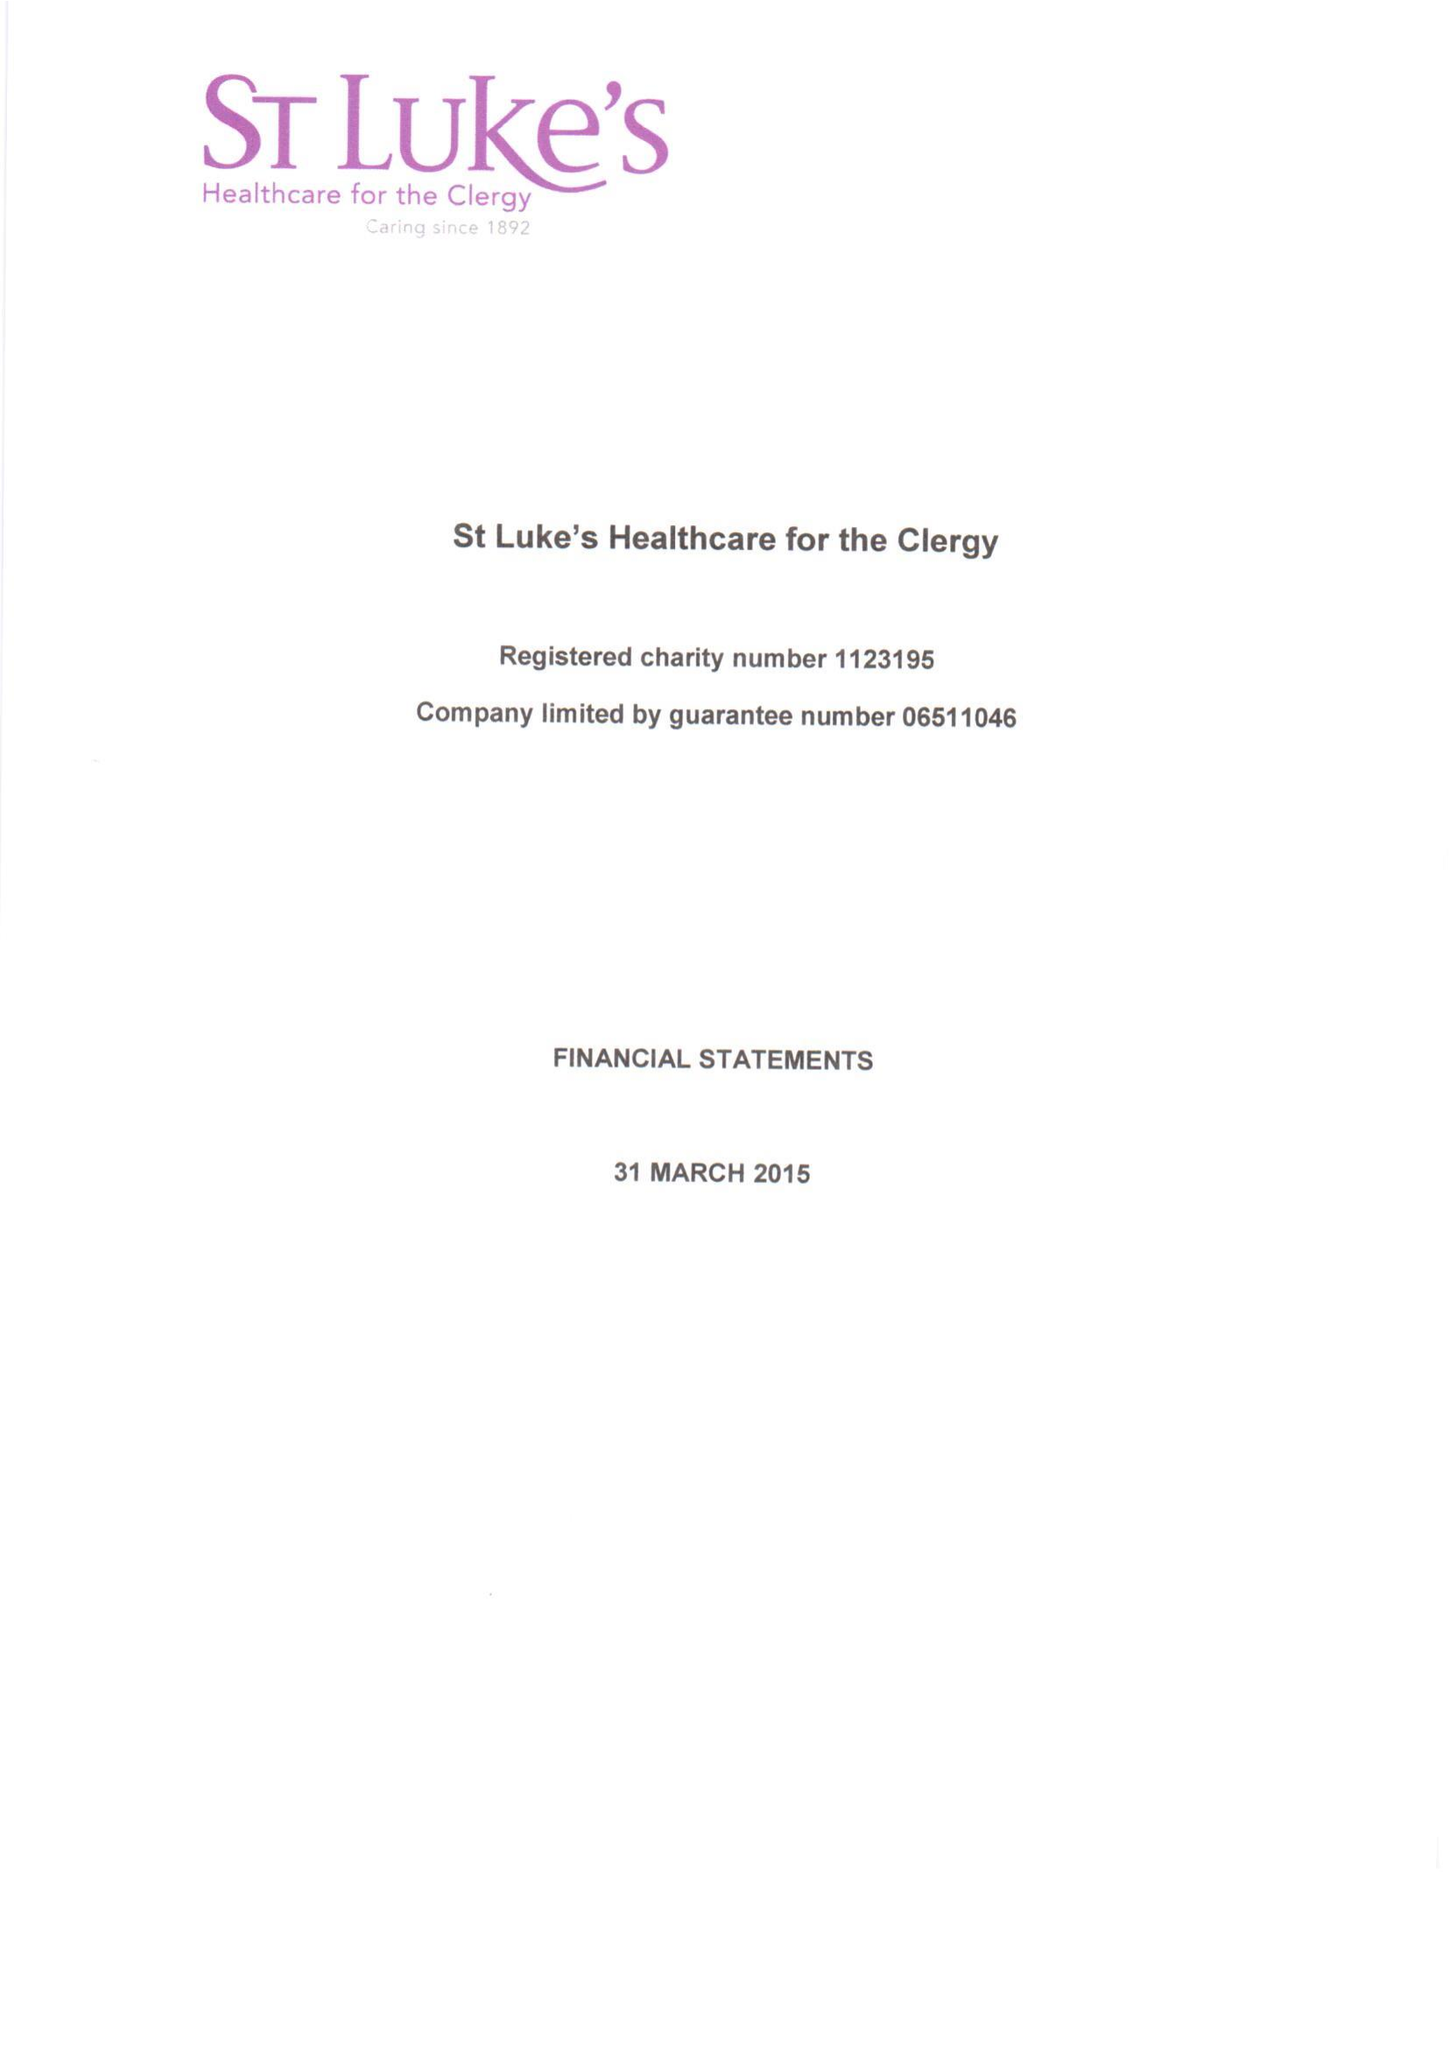What is the value for the address__post_town?
Answer the question using a single word or phrase. LONDON 